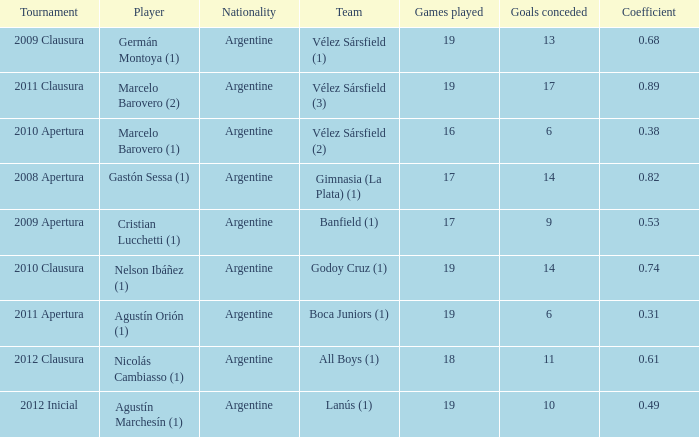What is the nationality of the 2012 clausura  tournament? Argentine. 